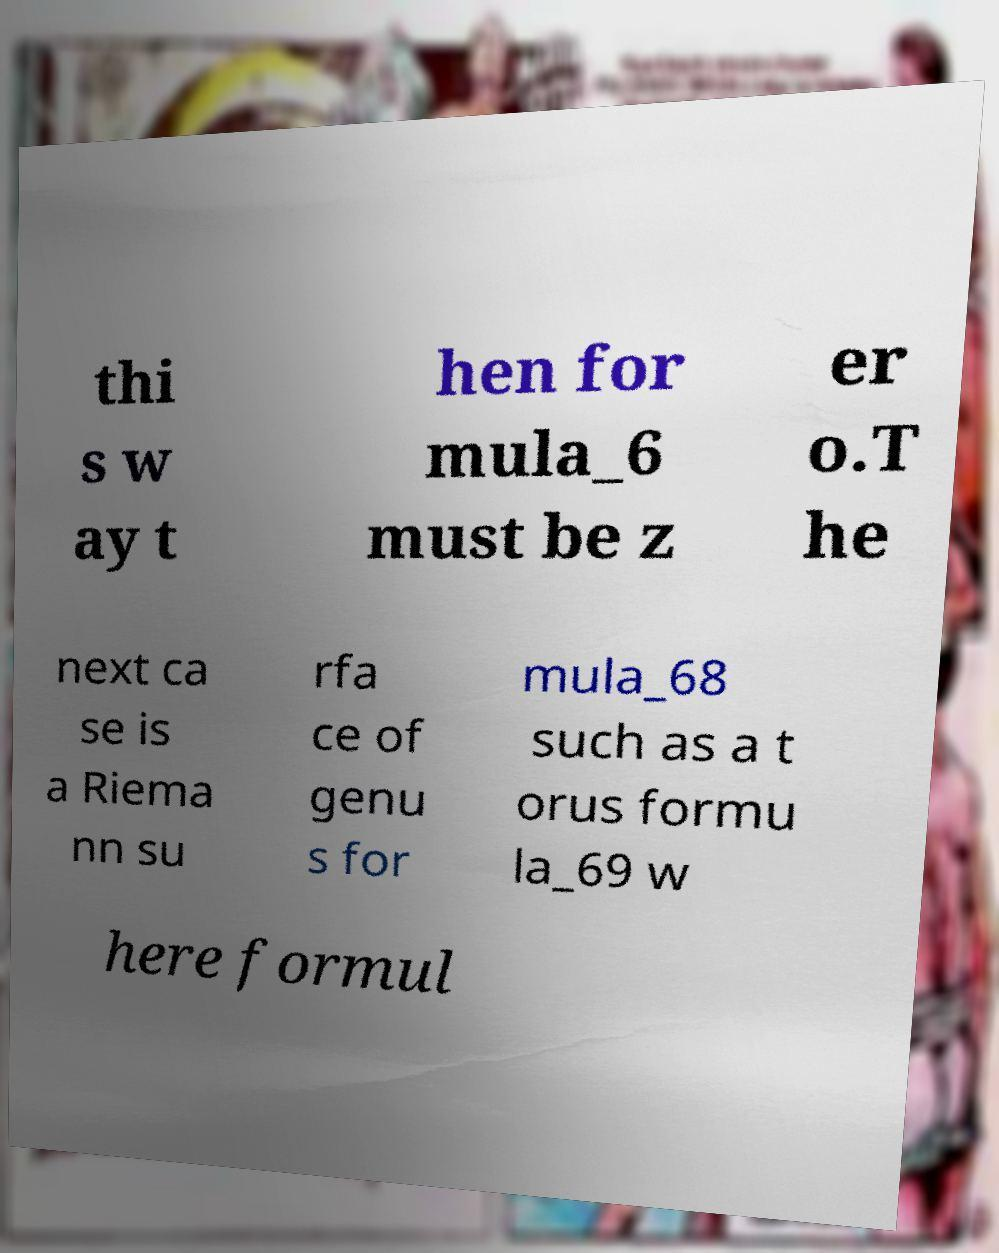Please identify and transcribe the text found in this image. thi s w ay t hen for mula_6 must be z er o.T he next ca se is a Riema nn su rfa ce of genu s for mula_68 such as a t orus formu la_69 w here formul 